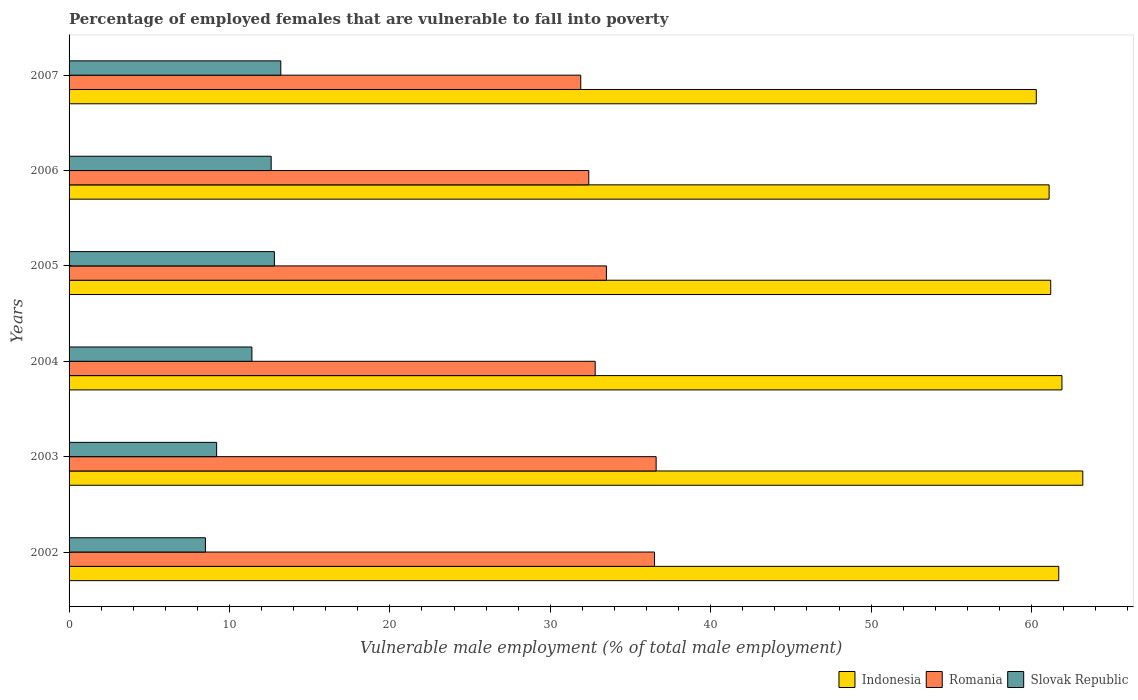Are the number of bars per tick equal to the number of legend labels?
Keep it short and to the point. Yes. Are the number of bars on each tick of the Y-axis equal?
Offer a terse response. Yes. How many bars are there on the 2nd tick from the top?
Ensure brevity in your answer.  3. How many bars are there on the 4th tick from the bottom?
Your response must be concise. 3. What is the label of the 5th group of bars from the top?
Offer a very short reply. 2003. In how many cases, is the number of bars for a given year not equal to the number of legend labels?
Your answer should be very brief. 0. What is the percentage of employed females who are vulnerable to fall into poverty in Indonesia in 2003?
Your answer should be compact. 63.2. Across all years, what is the maximum percentage of employed females who are vulnerable to fall into poverty in Indonesia?
Ensure brevity in your answer.  63.2. Across all years, what is the minimum percentage of employed females who are vulnerable to fall into poverty in Slovak Republic?
Make the answer very short. 8.5. In which year was the percentage of employed females who are vulnerable to fall into poverty in Romania minimum?
Provide a succinct answer. 2007. What is the total percentage of employed females who are vulnerable to fall into poverty in Indonesia in the graph?
Keep it short and to the point. 369.4. What is the difference between the percentage of employed females who are vulnerable to fall into poverty in Indonesia in 2004 and that in 2005?
Your response must be concise. 0.7. What is the difference between the percentage of employed females who are vulnerable to fall into poverty in Romania in 2005 and the percentage of employed females who are vulnerable to fall into poverty in Slovak Republic in 2007?
Give a very brief answer. 20.3. What is the average percentage of employed females who are vulnerable to fall into poverty in Indonesia per year?
Make the answer very short. 61.57. In the year 2002, what is the difference between the percentage of employed females who are vulnerable to fall into poverty in Romania and percentage of employed females who are vulnerable to fall into poverty in Slovak Republic?
Provide a succinct answer. 28. In how many years, is the percentage of employed females who are vulnerable to fall into poverty in Romania greater than 56 %?
Make the answer very short. 0. What is the ratio of the percentage of employed females who are vulnerable to fall into poverty in Romania in 2006 to that in 2007?
Offer a very short reply. 1.02. What is the difference between the highest and the second highest percentage of employed females who are vulnerable to fall into poverty in Slovak Republic?
Your response must be concise. 0.4. What is the difference between the highest and the lowest percentage of employed females who are vulnerable to fall into poverty in Romania?
Offer a very short reply. 4.7. In how many years, is the percentage of employed females who are vulnerable to fall into poverty in Indonesia greater than the average percentage of employed females who are vulnerable to fall into poverty in Indonesia taken over all years?
Ensure brevity in your answer.  3. Are all the bars in the graph horizontal?
Your answer should be compact. Yes. How many years are there in the graph?
Make the answer very short. 6. What is the difference between two consecutive major ticks on the X-axis?
Your answer should be very brief. 10. Does the graph contain grids?
Your answer should be compact. No. How many legend labels are there?
Your answer should be compact. 3. How are the legend labels stacked?
Give a very brief answer. Horizontal. What is the title of the graph?
Keep it short and to the point. Percentage of employed females that are vulnerable to fall into poverty. Does "Poland" appear as one of the legend labels in the graph?
Your answer should be very brief. No. What is the label or title of the X-axis?
Provide a succinct answer. Vulnerable male employment (% of total male employment). What is the Vulnerable male employment (% of total male employment) of Indonesia in 2002?
Your response must be concise. 61.7. What is the Vulnerable male employment (% of total male employment) of Romania in 2002?
Your answer should be very brief. 36.5. What is the Vulnerable male employment (% of total male employment) of Slovak Republic in 2002?
Your answer should be compact. 8.5. What is the Vulnerable male employment (% of total male employment) of Indonesia in 2003?
Your response must be concise. 63.2. What is the Vulnerable male employment (% of total male employment) of Romania in 2003?
Your response must be concise. 36.6. What is the Vulnerable male employment (% of total male employment) of Slovak Republic in 2003?
Keep it short and to the point. 9.2. What is the Vulnerable male employment (% of total male employment) of Indonesia in 2004?
Provide a succinct answer. 61.9. What is the Vulnerable male employment (% of total male employment) in Romania in 2004?
Provide a succinct answer. 32.8. What is the Vulnerable male employment (% of total male employment) in Slovak Republic in 2004?
Offer a terse response. 11.4. What is the Vulnerable male employment (% of total male employment) of Indonesia in 2005?
Make the answer very short. 61.2. What is the Vulnerable male employment (% of total male employment) in Romania in 2005?
Offer a terse response. 33.5. What is the Vulnerable male employment (% of total male employment) in Slovak Republic in 2005?
Ensure brevity in your answer.  12.8. What is the Vulnerable male employment (% of total male employment) in Indonesia in 2006?
Ensure brevity in your answer.  61.1. What is the Vulnerable male employment (% of total male employment) in Romania in 2006?
Offer a very short reply. 32.4. What is the Vulnerable male employment (% of total male employment) of Slovak Republic in 2006?
Offer a very short reply. 12.6. What is the Vulnerable male employment (% of total male employment) of Indonesia in 2007?
Make the answer very short. 60.3. What is the Vulnerable male employment (% of total male employment) in Romania in 2007?
Offer a very short reply. 31.9. What is the Vulnerable male employment (% of total male employment) of Slovak Republic in 2007?
Keep it short and to the point. 13.2. Across all years, what is the maximum Vulnerable male employment (% of total male employment) of Indonesia?
Provide a short and direct response. 63.2. Across all years, what is the maximum Vulnerable male employment (% of total male employment) in Romania?
Provide a short and direct response. 36.6. Across all years, what is the maximum Vulnerable male employment (% of total male employment) of Slovak Republic?
Provide a short and direct response. 13.2. Across all years, what is the minimum Vulnerable male employment (% of total male employment) of Indonesia?
Offer a very short reply. 60.3. Across all years, what is the minimum Vulnerable male employment (% of total male employment) of Romania?
Provide a short and direct response. 31.9. What is the total Vulnerable male employment (% of total male employment) of Indonesia in the graph?
Your response must be concise. 369.4. What is the total Vulnerable male employment (% of total male employment) of Romania in the graph?
Your answer should be very brief. 203.7. What is the total Vulnerable male employment (% of total male employment) of Slovak Republic in the graph?
Your response must be concise. 67.7. What is the difference between the Vulnerable male employment (% of total male employment) of Slovak Republic in 2002 and that in 2003?
Ensure brevity in your answer.  -0.7. What is the difference between the Vulnerable male employment (% of total male employment) of Romania in 2002 and that in 2004?
Your answer should be compact. 3.7. What is the difference between the Vulnerable male employment (% of total male employment) of Slovak Republic in 2002 and that in 2004?
Offer a terse response. -2.9. What is the difference between the Vulnerable male employment (% of total male employment) of Indonesia in 2002 and that in 2006?
Provide a succinct answer. 0.6. What is the difference between the Vulnerable male employment (% of total male employment) in Indonesia in 2002 and that in 2007?
Your answer should be compact. 1.4. What is the difference between the Vulnerable male employment (% of total male employment) in Romania in 2002 and that in 2007?
Provide a short and direct response. 4.6. What is the difference between the Vulnerable male employment (% of total male employment) of Slovak Republic in 2003 and that in 2004?
Provide a succinct answer. -2.2. What is the difference between the Vulnerable male employment (% of total male employment) in Indonesia in 2003 and that in 2005?
Your response must be concise. 2. What is the difference between the Vulnerable male employment (% of total male employment) of Romania in 2003 and that in 2005?
Your answer should be very brief. 3.1. What is the difference between the Vulnerable male employment (% of total male employment) in Slovak Republic in 2003 and that in 2005?
Offer a terse response. -3.6. What is the difference between the Vulnerable male employment (% of total male employment) in Indonesia in 2003 and that in 2006?
Offer a terse response. 2.1. What is the difference between the Vulnerable male employment (% of total male employment) in Slovak Republic in 2003 and that in 2006?
Your response must be concise. -3.4. What is the difference between the Vulnerable male employment (% of total male employment) in Indonesia in 2003 and that in 2007?
Provide a short and direct response. 2.9. What is the difference between the Vulnerable male employment (% of total male employment) of Romania in 2003 and that in 2007?
Your answer should be compact. 4.7. What is the difference between the Vulnerable male employment (% of total male employment) of Slovak Republic in 2003 and that in 2007?
Make the answer very short. -4. What is the difference between the Vulnerable male employment (% of total male employment) in Indonesia in 2004 and that in 2006?
Provide a succinct answer. 0.8. What is the difference between the Vulnerable male employment (% of total male employment) in Romania in 2004 and that in 2006?
Offer a terse response. 0.4. What is the difference between the Vulnerable male employment (% of total male employment) in Slovak Republic in 2004 and that in 2006?
Offer a terse response. -1.2. What is the difference between the Vulnerable male employment (% of total male employment) of Indonesia in 2004 and that in 2007?
Ensure brevity in your answer.  1.6. What is the difference between the Vulnerable male employment (% of total male employment) of Romania in 2004 and that in 2007?
Your answer should be very brief. 0.9. What is the difference between the Vulnerable male employment (% of total male employment) of Romania in 2005 and that in 2006?
Provide a succinct answer. 1.1. What is the difference between the Vulnerable male employment (% of total male employment) in Romania in 2005 and that in 2007?
Your answer should be very brief. 1.6. What is the difference between the Vulnerable male employment (% of total male employment) of Indonesia in 2006 and that in 2007?
Make the answer very short. 0.8. What is the difference between the Vulnerable male employment (% of total male employment) of Romania in 2006 and that in 2007?
Offer a terse response. 0.5. What is the difference between the Vulnerable male employment (% of total male employment) of Indonesia in 2002 and the Vulnerable male employment (% of total male employment) of Romania in 2003?
Give a very brief answer. 25.1. What is the difference between the Vulnerable male employment (% of total male employment) in Indonesia in 2002 and the Vulnerable male employment (% of total male employment) in Slovak Republic in 2003?
Your response must be concise. 52.5. What is the difference between the Vulnerable male employment (% of total male employment) in Romania in 2002 and the Vulnerable male employment (% of total male employment) in Slovak Republic in 2003?
Make the answer very short. 27.3. What is the difference between the Vulnerable male employment (% of total male employment) of Indonesia in 2002 and the Vulnerable male employment (% of total male employment) of Romania in 2004?
Give a very brief answer. 28.9. What is the difference between the Vulnerable male employment (% of total male employment) in Indonesia in 2002 and the Vulnerable male employment (% of total male employment) in Slovak Republic in 2004?
Your response must be concise. 50.3. What is the difference between the Vulnerable male employment (% of total male employment) of Romania in 2002 and the Vulnerable male employment (% of total male employment) of Slovak Republic in 2004?
Your answer should be compact. 25.1. What is the difference between the Vulnerable male employment (% of total male employment) of Indonesia in 2002 and the Vulnerable male employment (% of total male employment) of Romania in 2005?
Your answer should be compact. 28.2. What is the difference between the Vulnerable male employment (% of total male employment) of Indonesia in 2002 and the Vulnerable male employment (% of total male employment) of Slovak Republic in 2005?
Make the answer very short. 48.9. What is the difference between the Vulnerable male employment (% of total male employment) of Romania in 2002 and the Vulnerable male employment (% of total male employment) of Slovak Republic in 2005?
Provide a succinct answer. 23.7. What is the difference between the Vulnerable male employment (% of total male employment) in Indonesia in 2002 and the Vulnerable male employment (% of total male employment) in Romania in 2006?
Provide a short and direct response. 29.3. What is the difference between the Vulnerable male employment (% of total male employment) in Indonesia in 2002 and the Vulnerable male employment (% of total male employment) in Slovak Republic in 2006?
Offer a terse response. 49.1. What is the difference between the Vulnerable male employment (% of total male employment) of Romania in 2002 and the Vulnerable male employment (% of total male employment) of Slovak Republic in 2006?
Offer a very short reply. 23.9. What is the difference between the Vulnerable male employment (% of total male employment) of Indonesia in 2002 and the Vulnerable male employment (% of total male employment) of Romania in 2007?
Your answer should be compact. 29.8. What is the difference between the Vulnerable male employment (% of total male employment) in Indonesia in 2002 and the Vulnerable male employment (% of total male employment) in Slovak Republic in 2007?
Offer a terse response. 48.5. What is the difference between the Vulnerable male employment (% of total male employment) of Romania in 2002 and the Vulnerable male employment (% of total male employment) of Slovak Republic in 2007?
Ensure brevity in your answer.  23.3. What is the difference between the Vulnerable male employment (% of total male employment) of Indonesia in 2003 and the Vulnerable male employment (% of total male employment) of Romania in 2004?
Your answer should be very brief. 30.4. What is the difference between the Vulnerable male employment (% of total male employment) in Indonesia in 2003 and the Vulnerable male employment (% of total male employment) in Slovak Republic in 2004?
Offer a very short reply. 51.8. What is the difference between the Vulnerable male employment (% of total male employment) in Romania in 2003 and the Vulnerable male employment (% of total male employment) in Slovak Republic in 2004?
Offer a terse response. 25.2. What is the difference between the Vulnerable male employment (% of total male employment) of Indonesia in 2003 and the Vulnerable male employment (% of total male employment) of Romania in 2005?
Your answer should be very brief. 29.7. What is the difference between the Vulnerable male employment (% of total male employment) of Indonesia in 2003 and the Vulnerable male employment (% of total male employment) of Slovak Republic in 2005?
Give a very brief answer. 50.4. What is the difference between the Vulnerable male employment (% of total male employment) of Romania in 2003 and the Vulnerable male employment (% of total male employment) of Slovak Republic in 2005?
Your answer should be compact. 23.8. What is the difference between the Vulnerable male employment (% of total male employment) of Indonesia in 2003 and the Vulnerable male employment (% of total male employment) of Romania in 2006?
Your answer should be compact. 30.8. What is the difference between the Vulnerable male employment (% of total male employment) in Indonesia in 2003 and the Vulnerable male employment (% of total male employment) in Slovak Republic in 2006?
Make the answer very short. 50.6. What is the difference between the Vulnerable male employment (% of total male employment) in Romania in 2003 and the Vulnerable male employment (% of total male employment) in Slovak Republic in 2006?
Offer a terse response. 24. What is the difference between the Vulnerable male employment (% of total male employment) in Indonesia in 2003 and the Vulnerable male employment (% of total male employment) in Romania in 2007?
Ensure brevity in your answer.  31.3. What is the difference between the Vulnerable male employment (% of total male employment) of Indonesia in 2003 and the Vulnerable male employment (% of total male employment) of Slovak Republic in 2007?
Your answer should be compact. 50. What is the difference between the Vulnerable male employment (% of total male employment) in Romania in 2003 and the Vulnerable male employment (% of total male employment) in Slovak Republic in 2007?
Your answer should be very brief. 23.4. What is the difference between the Vulnerable male employment (% of total male employment) in Indonesia in 2004 and the Vulnerable male employment (% of total male employment) in Romania in 2005?
Ensure brevity in your answer.  28.4. What is the difference between the Vulnerable male employment (% of total male employment) of Indonesia in 2004 and the Vulnerable male employment (% of total male employment) of Slovak Republic in 2005?
Provide a short and direct response. 49.1. What is the difference between the Vulnerable male employment (% of total male employment) in Romania in 2004 and the Vulnerable male employment (% of total male employment) in Slovak Republic in 2005?
Offer a terse response. 20. What is the difference between the Vulnerable male employment (% of total male employment) in Indonesia in 2004 and the Vulnerable male employment (% of total male employment) in Romania in 2006?
Provide a short and direct response. 29.5. What is the difference between the Vulnerable male employment (% of total male employment) of Indonesia in 2004 and the Vulnerable male employment (% of total male employment) of Slovak Republic in 2006?
Your response must be concise. 49.3. What is the difference between the Vulnerable male employment (% of total male employment) in Romania in 2004 and the Vulnerable male employment (% of total male employment) in Slovak Republic in 2006?
Give a very brief answer. 20.2. What is the difference between the Vulnerable male employment (% of total male employment) in Indonesia in 2004 and the Vulnerable male employment (% of total male employment) in Slovak Republic in 2007?
Provide a succinct answer. 48.7. What is the difference between the Vulnerable male employment (% of total male employment) in Romania in 2004 and the Vulnerable male employment (% of total male employment) in Slovak Republic in 2007?
Offer a terse response. 19.6. What is the difference between the Vulnerable male employment (% of total male employment) in Indonesia in 2005 and the Vulnerable male employment (% of total male employment) in Romania in 2006?
Make the answer very short. 28.8. What is the difference between the Vulnerable male employment (% of total male employment) of Indonesia in 2005 and the Vulnerable male employment (% of total male employment) of Slovak Republic in 2006?
Ensure brevity in your answer.  48.6. What is the difference between the Vulnerable male employment (% of total male employment) of Romania in 2005 and the Vulnerable male employment (% of total male employment) of Slovak Republic in 2006?
Offer a very short reply. 20.9. What is the difference between the Vulnerable male employment (% of total male employment) in Indonesia in 2005 and the Vulnerable male employment (% of total male employment) in Romania in 2007?
Your response must be concise. 29.3. What is the difference between the Vulnerable male employment (% of total male employment) of Romania in 2005 and the Vulnerable male employment (% of total male employment) of Slovak Republic in 2007?
Offer a very short reply. 20.3. What is the difference between the Vulnerable male employment (% of total male employment) in Indonesia in 2006 and the Vulnerable male employment (% of total male employment) in Romania in 2007?
Keep it short and to the point. 29.2. What is the difference between the Vulnerable male employment (% of total male employment) of Indonesia in 2006 and the Vulnerable male employment (% of total male employment) of Slovak Republic in 2007?
Offer a terse response. 47.9. What is the average Vulnerable male employment (% of total male employment) in Indonesia per year?
Your answer should be compact. 61.57. What is the average Vulnerable male employment (% of total male employment) of Romania per year?
Your answer should be very brief. 33.95. What is the average Vulnerable male employment (% of total male employment) in Slovak Republic per year?
Provide a succinct answer. 11.28. In the year 2002, what is the difference between the Vulnerable male employment (% of total male employment) of Indonesia and Vulnerable male employment (% of total male employment) of Romania?
Your response must be concise. 25.2. In the year 2002, what is the difference between the Vulnerable male employment (% of total male employment) in Indonesia and Vulnerable male employment (% of total male employment) in Slovak Republic?
Ensure brevity in your answer.  53.2. In the year 2002, what is the difference between the Vulnerable male employment (% of total male employment) in Romania and Vulnerable male employment (% of total male employment) in Slovak Republic?
Your answer should be very brief. 28. In the year 2003, what is the difference between the Vulnerable male employment (% of total male employment) of Indonesia and Vulnerable male employment (% of total male employment) of Romania?
Your answer should be compact. 26.6. In the year 2003, what is the difference between the Vulnerable male employment (% of total male employment) in Romania and Vulnerable male employment (% of total male employment) in Slovak Republic?
Your answer should be compact. 27.4. In the year 2004, what is the difference between the Vulnerable male employment (% of total male employment) of Indonesia and Vulnerable male employment (% of total male employment) of Romania?
Give a very brief answer. 29.1. In the year 2004, what is the difference between the Vulnerable male employment (% of total male employment) in Indonesia and Vulnerable male employment (% of total male employment) in Slovak Republic?
Ensure brevity in your answer.  50.5. In the year 2004, what is the difference between the Vulnerable male employment (% of total male employment) of Romania and Vulnerable male employment (% of total male employment) of Slovak Republic?
Your answer should be very brief. 21.4. In the year 2005, what is the difference between the Vulnerable male employment (% of total male employment) in Indonesia and Vulnerable male employment (% of total male employment) in Romania?
Make the answer very short. 27.7. In the year 2005, what is the difference between the Vulnerable male employment (% of total male employment) in Indonesia and Vulnerable male employment (% of total male employment) in Slovak Republic?
Your response must be concise. 48.4. In the year 2005, what is the difference between the Vulnerable male employment (% of total male employment) of Romania and Vulnerable male employment (% of total male employment) of Slovak Republic?
Make the answer very short. 20.7. In the year 2006, what is the difference between the Vulnerable male employment (% of total male employment) in Indonesia and Vulnerable male employment (% of total male employment) in Romania?
Give a very brief answer. 28.7. In the year 2006, what is the difference between the Vulnerable male employment (% of total male employment) of Indonesia and Vulnerable male employment (% of total male employment) of Slovak Republic?
Provide a succinct answer. 48.5. In the year 2006, what is the difference between the Vulnerable male employment (% of total male employment) in Romania and Vulnerable male employment (% of total male employment) in Slovak Republic?
Give a very brief answer. 19.8. In the year 2007, what is the difference between the Vulnerable male employment (% of total male employment) of Indonesia and Vulnerable male employment (% of total male employment) of Romania?
Your response must be concise. 28.4. In the year 2007, what is the difference between the Vulnerable male employment (% of total male employment) of Indonesia and Vulnerable male employment (% of total male employment) of Slovak Republic?
Provide a succinct answer. 47.1. What is the ratio of the Vulnerable male employment (% of total male employment) in Indonesia in 2002 to that in 2003?
Ensure brevity in your answer.  0.98. What is the ratio of the Vulnerable male employment (% of total male employment) of Slovak Republic in 2002 to that in 2003?
Give a very brief answer. 0.92. What is the ratio of the Vulnerable male employment (% of total male employment) of Indonesia in 2002 to that in 2004?
Your answer should be compact. 1. What is the ratio of the Vulnerable male employment (% of total male employment) of Romania in 2002 to that in 2004?
Offer a terse response. 1.11. What is the ratio of the Vulnerable male employment (% of total male employment) of Slovak Republic in 2002 to that in 2004?
Keep it short and to the point. 0.75. What is the ratio of the Vulnerable male employment (% of total male employment) in Indonesia in 2002 to that in 2005?
Provide a succinct answer. 1.01. What is the ratio of the Vulnerable male employment (% of total male employment) in Romania in 2002 to that in 2005?
Provide a short and direct response. 1.09. What is the ratio of the Vulnerable male employment (% of total male employment) in Slovak Republic in 2002 to that in 2005?
Offer a terse response. 0.66. What is the ratio of the Vulnerable male employment (% of total male employment) in Indonesia in 2002 to that in 2006?
Ensure brevity in your answer.  1.01. What is the ratio of the Vulnerable male employment (% of total male employment) in Romania in 2002 to that in 2006?
Your response must be concise. 1.13. What is the ratio of the Vulnerable male employment (% of total male employment) of Slovak Republic in 2002 to that in 2006?
Your answer should be compact. 0.67. What is the ratio of the Vulnerable male employment (% of total male employment) in Indonesia in 2002 to that in 2007?
Your answer should be very brief. 1.02. What is the ratio of the Vulnerable male employment (% of total male employment) in Romania in 2002 to that in 2007?
Provide a succinct answer. 1.14. What is the ratio of the Vulnerable male employment (% of total male employment) of Slovak Republic in 2002 to that in 2007?
Provide a succinct answer. 0.64. What is the ratio of the Vulnerable male employment (% of total male employment) of Indonesia in 2003 to that in 2004?
Your answer should be compact. 1.02. What is the ratio of the Vulnerable male employment (% of total male employment) of Romania in 2003 to that in 2004?
Your answer should be compact. 1.12. What is the ratio of the Vulnerable male employment (% of total male employment) in Slovak Republic in 2003 to that in 2004?
Ensure brevity in your answer.  0.81. What is the ratio of the Vulnerable male employment (% of total male employment) in Indonesia in 2003 to that in 2005?
Keep it short and to the point. 1.03. What is the ratio of the Vulnerable male employment (% of total male employment) in Romania in 2003 to that in 2005?
Give a very brief answer. 1.09. What is the ratio of the Vulnerable male employment (% of total male employment) in Slovak Republic in 2003 to that in 2005?
Give a very brief answer. 0.72. What is the ratio of the Vulnerable male employment (% of total male employment) in Indonesia in 2003 to that in 2006?
Provide a short and direct response. 1.03. What is the ratio of the Vulnerable male employment (% of total male employment) in Romania in 2003 to that in 2006?
Keep it short and to the point. 1.13. What is the ratio of the Vulnerable male employment (% of total male employment) of Slovak Republic in 2003 to that in 2006?
Ensure brevity in your answer.  0.73. What is the ratio of the Vulnerable male employment (% of total male employment) in Indonesia in 2003 to that in 2007?
Offer a very short reply. 1.05. What is the ratio of the Vulnerable male employment (% of total male employment) of Romania in 2003 to that in 2007?
Provide a succinct answer. 1.15. What is the ratio of the Vulnerable male employment (% of total male employment) in Slovak Republic in 2003 to that in 2007?
Your answer should be very brief. 0.7. What is the ratio of the Vulnerable male employment (% of total male employment) in Indonesia in 2004 to that in 2005?
Keep it short and to the point. 1.01. What is the ratio of the Vulnerable male employment (% of total male employment) in Romania in 2004 to that in 2005?
Give a very brief answer. 0.98. What is the ratio of the Vulnerable male employment (% of total male employment) of Slovak Republic in 2004 to that in 2005?
Offer a terse response. 0.89. What is the ratio of the Vulnerable male employment (% of total male employment) in Indonesia in 2004 to that in 2006?
Offer a terse response. 1.01. What is the ratio of the Vulnerable male employment (% of total male employment) in Romania in 2004 to that in 2006?
Provide a succinct answer. 1.01. What is the ratio of the Vulnerable male employment (% of total male employment) in Slovak Republic in 2004 to that in 2006?
Your answer should be very brief. 0.9. What is the ratio of the Vulnerable male employment (% of total male employment) in Indonesia in 2004 to that in 2007?
Your answer should be compact. 1.03. What is the ratio of the Vulnerable male employment (% of total male employment) in Romania in 2004 to that in 2007?
Provide a succinct answer. 1.03. What is the ratio of the Vulnerable male employment (% of total male employment) in Slovak Republic in 2004 to that in 2007?
Ensure brevity in your answer.  0.86. What is the ratio of the Vulnerable male employment (% of total male employment) in Indonesia in 2005 to that in 2006?
Your answer should be very brief. 1. What is the ratio of the Vulnerable male employment (% of total male employment) of Romania in 2005 to that in 2006?
Provide a succinct answer. 1.03. What is the ratio of the Vulnerable male employment (% of total male employment) in Slovak Republic in 2005 to that in 2006?
Your answer should be compact. 1.02. What is the ratio of the Vulnerable male employment (% of total male employment) of Indonesia in 2005 to that in 2007?
Offer a terse response. 1.01. What is the ratio of the Vulnerable male employment (% of total male employment) of Romania in 2005 to that in 2007?
Offer a very short reply. 1.05. What is the ratio of the Vulnerable male employment (% of total male employment) of Slovak Republic in 2005 to that in 2007?
Your answer should be very brief. 0.97. What is the ratio of the Vulnerable male employment (% of total male employment) of Indonesia in 2006 to that in 2007?
Your response must be concise. 1.01. What is the ratio of the Vulnerable male employment (% of total male employment) in Romania in 2006 to that in 2007?
Your answer should be compact. 1.02. What is the ratio of the Vulnerable male employment (% of total male employment) in Slovak Republic in 2006 to that in 2007?
Give a very brief answer. 0.95. What is the difference between the highest and the second highest Vulnerable male employment (% of total male employment) in Slovak Republic?
Offer a very short reply. 0.4. What is the difference between the highest and the lowest Vulnerable male employment (% of total male employment) of Indonesia?
Make the answer very short. 2.9. 